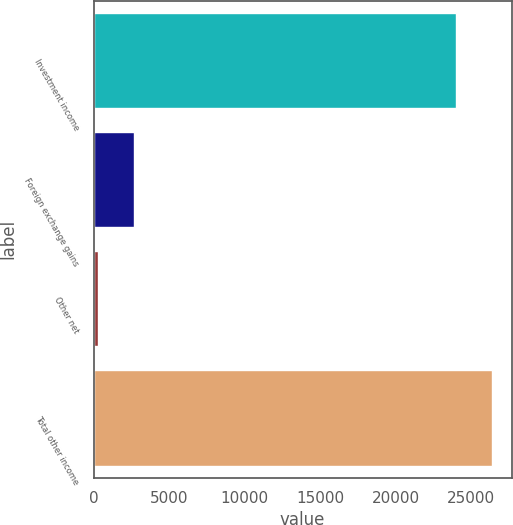Convert chart to OTSL. <chart><loc_0><loc_0><loc_500><loc_500><bar_chart><fcel>Investment income<fcel>Foreign exchange gains<fcel>Other net<fcel>Total other income<nl><fcel>23966<fcel>2688.1<fcel>299<fcel>26355.1<nl></chart> 